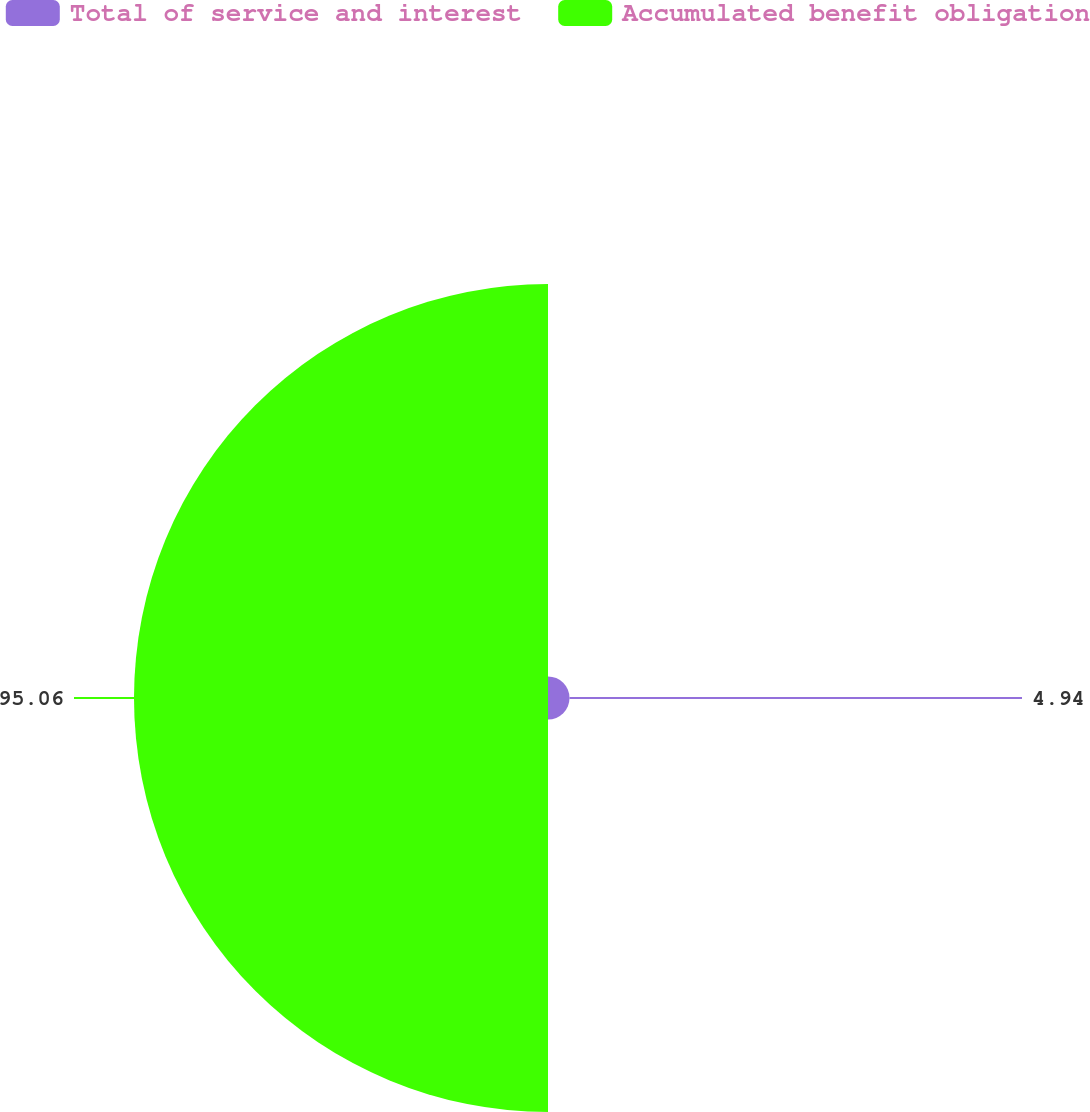Convert chart to OTSL. <chart><loc_0><loc_0><loc_500><loc_500><pie_chart><fcel>Total of service and interest<fcel>Accumulated benefit obligation<nl><fcel>4.94%<fcel>95.06%<nl></chart> 